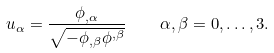Convert formula to latex. <formula><loc_0><loc_0><loc_500><loc_500>u _ { \alpha } = \frac { \phi _ { , \alpha } } { \sqrt { - \phi _ { , \beta } \phi ^ { , \beta } } } \quad \alpha , \beta = 0 , \dots , 3 .</formula> 